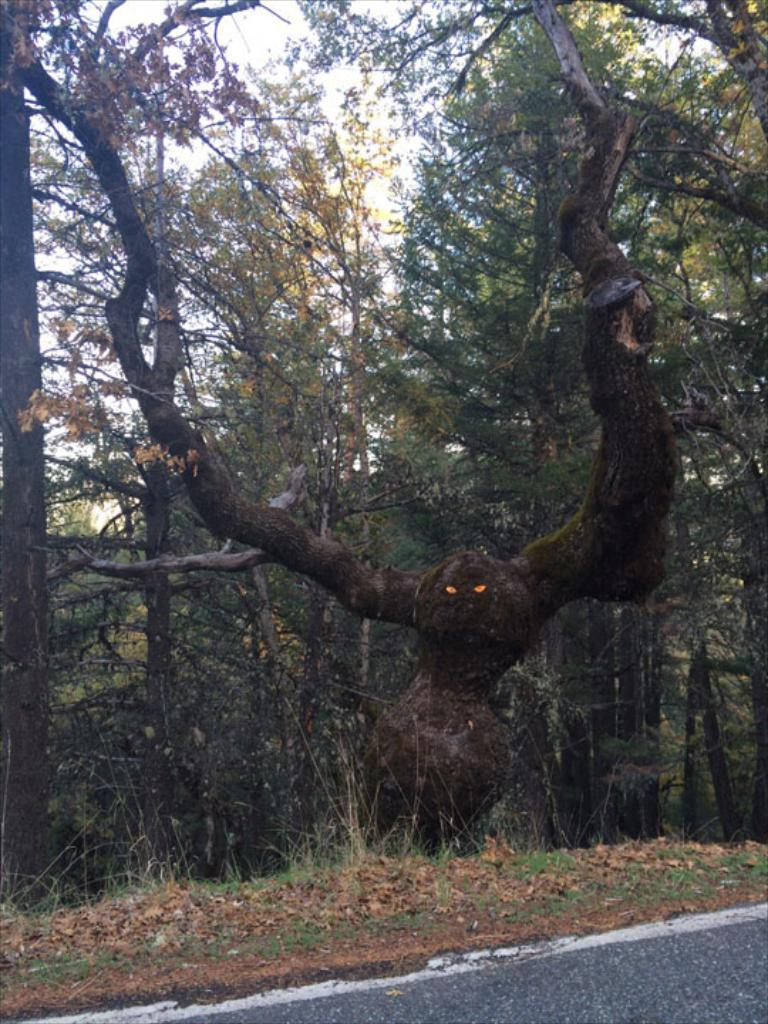What is the main feature of the image? There is a road in the image. What type of vegetation is near the road? There is grass near the road. What can be seen in the background of the image? There are trees and the sky visible in the background of the image. Reasoning: Let'g: Let's think step by step in order to produce the conversation. We start by identifying the main subject of the image, which is the road. Then, we describe the surrounding environment, including the grass near the road and the trees and sky in the background. Each question is designed to elicit a specific detail about the image that is known from the provided facts. Absurd Question/Answer: How many potatoes are being used to pave the road in the image? There are no potatoes present in the image; the road is not made of potatoes. Can you tell me the color of the bike in the image? There is no bike present in the image. 